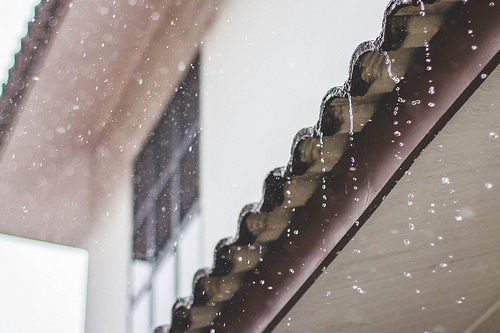<image>
Can you confirm if the overhang is next to the window? No. The overhang is not positioned next to the window. They are located in different areas of the scene. 